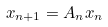<formula> <loc_0><loc_0><loc_500><loc_500>x _ { n + 1 } = A _ { n } x _ { n }</formula> 